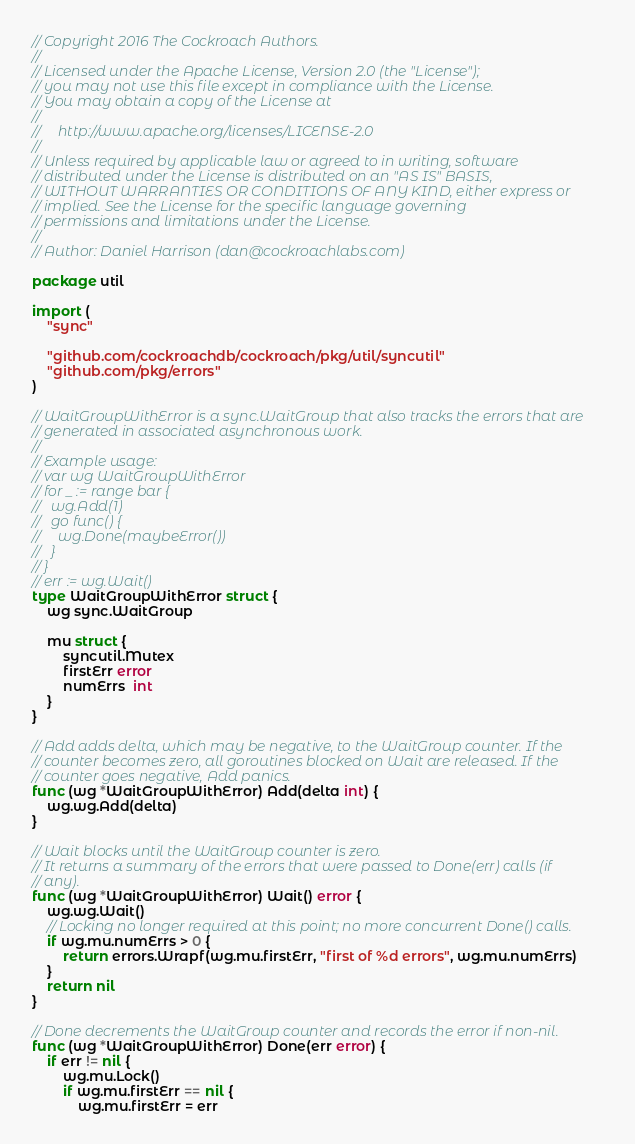Convert code to text. <code><loc_0><loc_0><loc_500><loc_500><_Go_>// Copyright 2016 The Cockroach Authors.
//
// Licensed under the Apache License, Version 2.0 (the "License");
// you may not use this file except in compliance with the License.
// You may obtain a copy of the License at
//
//     http://www.apache.org/licenses/LICENSE-2.0
//
// Unless required by applicable law or agreed to in writing, software
// distributed under the License is distributed on an "AS IS" BASIS,
// WITHOUT WARRANTIES OR CONDITIONS OF ANY KIND, either express or
// implied. See the License for the specific language governing
// permissions and limitations under the License.
//
// Author: Daniel Harrison (dan@cockroachlabs.com)

package util

import (
	"sync"

	"github.com/cockroachdb/cockroach/pkg/util/syncutil"
	"github.com/pkg/errors"
)

// WaitGroupWithError is a sync.WaitGroup that also tracks the errors that are
// generated in associated asynchronous work.
//
// Example usage:
// var wg WaitGroupWithError
// for _ := range bar {
//   wg.Add(1)
//   go func() {
//     wg.Done(maybeError())
//   }
// }
// err := wg.Wait()
type WaitGroupWithError struct {
	wg sync.WaitGroup

	mu struct {
		syncutil.Mutex
		firstErr error
		numErrs  int
	}
}

// Add adds delta, which may be negative, to the WaitGroup counter. If the
// counter becomes zero, all goroutines blocked on Wait are released. If the
// counter goes negative, Add panics.
func (wg *WaitGroupWithError) Add(delta int) {
	wg.wg.Add(delta)
}

// Wait blocks until the WaitGroup counter is zero.
// It returns a summary of the errors that were passed to Done(err) calls (if
// any).
func (wg *WaitGroupWithError) Wait() error {
	wg.wg.Wait()
	// Locking no longer required at this point; no more concurrent Done() calls.
	if wg.mu.numErrs > 0 {
		return errors.Wrapf(wg.mu.firstErr, "first of %d errors", wg.mu.numErrs)
	}
	return nil
}

// Done decrements the WaitGroup counter and records the error if non-nil.
func (wg *WaitGroupWithError) Done(err error) {
	if err != nil {
		wg.mu.Lock()
		if wg.mu.firstErr == nil {
			wg.mu.firstErr = err</code> 